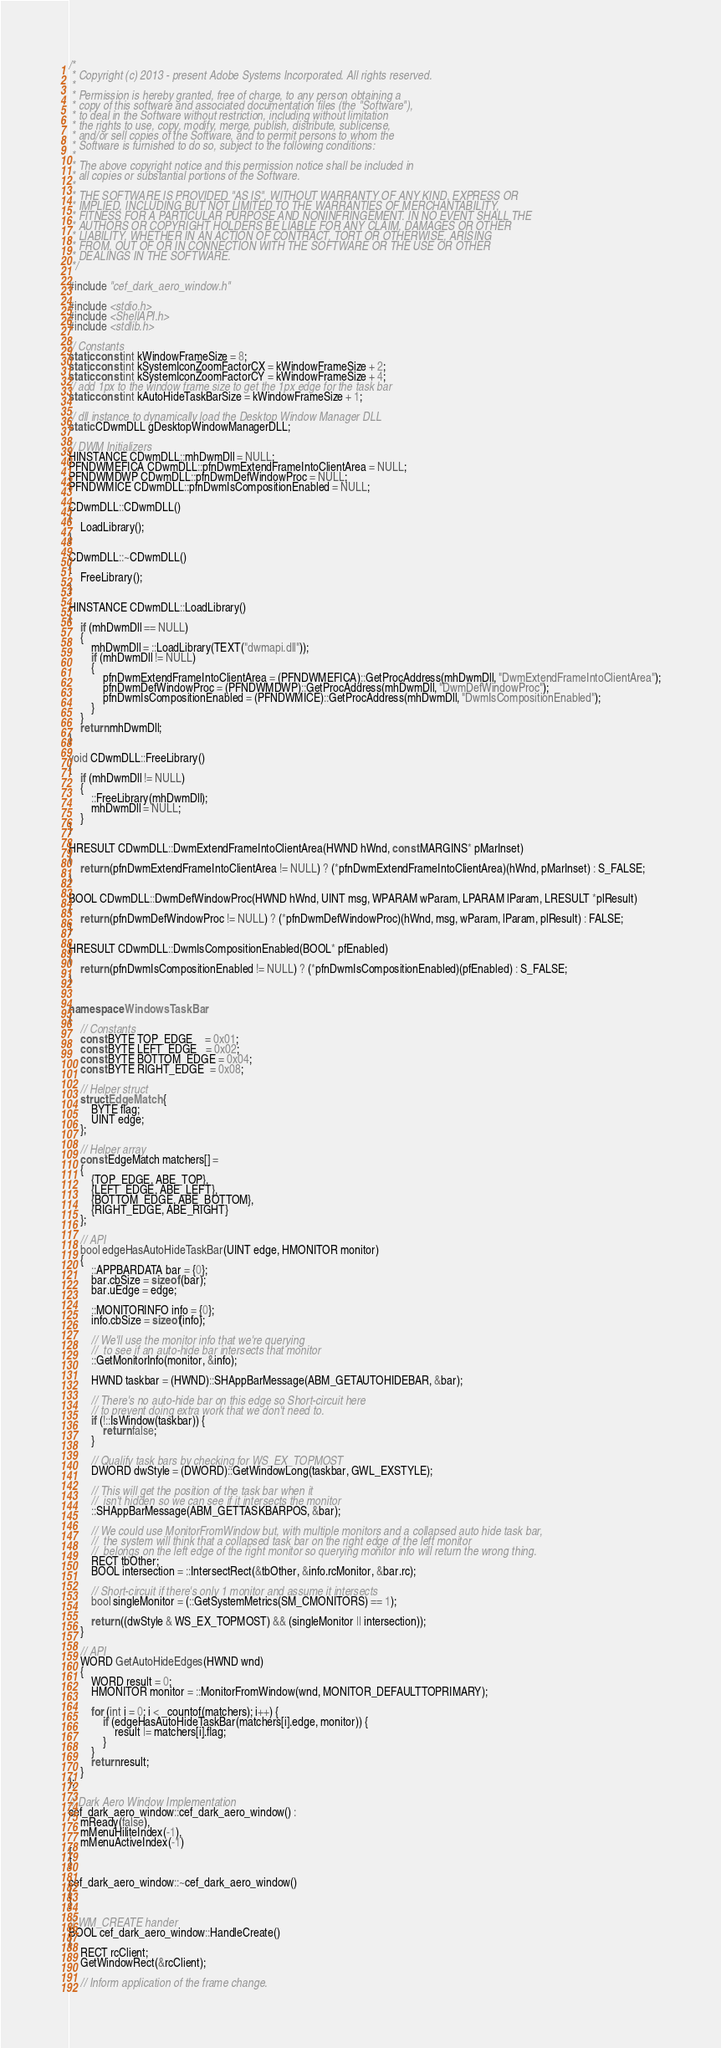Convert code to text. <code><loc_0><loc_0><loc_500><loc_500><_C++_>/*
 * Copyright (c) 2013 - present Adobe Systems Incorporated. All rights reserved.
 *
 * Permission is hereby granted, free of charge, to any person obtaining a
 * copy of this software and associated documentation files (the "Software"),
 * to deal in the Software without restriction, including without limitation
 * the rights to use, copy, modify, merge, publish, distribute, sublicense,
 * and/or sell copies of the Software, and to permit persons to whom the
 * Software is furnished to do so, subject to the following conditions:
 *
 * The above copyright notice and this permission notice shall be included in
 * all copies or substantial portions of the Software.
 *
 * THE SOFTWARE IS PROVIDED "AS IS", WITHOUT WARRANTY OF ANY KIND, EXPRESS OR
 * IMPLIED, INCLUDING BUT NOT LIMITED TO THE WARRANTIES OF MERCHANTABILITY,
 * FITNESS FOR A PARTICULAR PURPOSE AND NONINFRINGEMENT. IN NO EVENT SHALL THE
 * AUTHORS OR COPYRIGHT HOLDERS BE LIABLE FOR ANY CLAIM, DAMAGES OR OTHER
 * LIABILITY, WHETHER IN AN ACTION OF CONTRACT, TORT OR OTHERWISE, ARISING
 * FROM, OUT OF OR IN CONNECTION WITH THE SOFTWARE OR THE USE OR OTHER
 * DEALINGS IN THE SOFTWARE.
 */

#include "cef_dark_aero_window.h"

#include <stdio.h>
#include <ShellAPI.h>
#include <stdlib.h>

// Constants
static const int kWindowFrameSize = 8;
static const int kSystemIconZoomFactorCX = kWindowFrameSize + 2;
static const int kSystemIconZoomFactorCY = kWindowFrameSize + 4;
// add 1px to the window frame size to get the 1px edge for the task bar
static const int kAutoHideTaskBarSize = kWindowFrameSize + 1; 

// dll instance to dynamically load the Desktop Window Manager DLL
static CDwmDLL gDesktopWindowManagerDLL;

// DWM Initializers 
HINSTANCE CDwmDLL::mhDwmDll = NULL;
PFNDWMEFICA CDwmDLL::pfnDwmExtendFrameIntoClientArea = NULL;
PFNDWMDWP CDwmDLL::pfnDwmDefWindowProc = NULL;
PFNDWMICE CDwmDLL::pfnDwmIsCompositionEnabled = NULL;

CDwmDLL::CDwmDLL()
{
    LoadLibrary();
}

CDwmDLL::~CDwmDLL()
{
    FreeLibrary();
}

HINSTANCE CDwmDLL::LoadLibrary()
{
    if (mhDwmDll == NULL)
    {
        mhDwmDll = ::LoadLibrary(TEXT("dwmapi.dll"));
        if (mhDwmDll != NULL)
        {
            pfnDwmExtendFrameIntoClientArea = (PFNDWMEFICA)::GetProcAddress(mhDwmDll, "DwmExtendFrameIntoClientArea");
            pfnDwmDefWindowProc = (PFNDWMDWP)::GetProcAddress(mhDwmDll, "DwmDefWindowProc");
            pfnDwmIsCompositionEnabled = (PFNDWMICE)::GetProcAddress(mhDwmDll, "DwmIsCompositionEnabled");
        }
    }
    return mhDwmDll;
}

void CDwmDLL::FreeLibrary()
{
    if (mhDwmDll != NULL)
    {
        ::FreeLibrary(mhDwmDll);
        mhDwmDll = NULL;
    }
}

HRESULT CDwmDLL::DwmExtendFrameIntoClientArea(HWND hWnd, const MARGINS* pMarInset)
{
    return (pfnDwmExtendFrameIntoClientArea != NULL) ? (*pfnDwmExtendFrameIntoClientArea)(hWnd, pMarInset) : S_FALSE;
}

BOOL CDwmDLL::DwmDefWindowProc(HWND hWnd, UINT msg, WPARAM wParam, LPARAM lParam, LRESULT *plResult)
{
    return (pfnDwmDefWindowProc != NULL) ? (*pfnDwmDefWindowProc)(hWnd, msg, wParam, lParam, plResult) : FALSE;
}

HRESULT CDwmDLL::DwmIsCompositionEnabled(BOOL* pfEnabled)
{
    return (pfnDwmIsCompositionEnabled != NULL) ? (*pfnDwmIsCompositionEnabled)(pfEnabled) : S_FALSE;
}


namespace WindowsTaskBar
{
    // Constants
    const BYTE TOP_EDGE    = 0x01;
    const BYTE LEFT_EDGE   = 0x02;
    const BYTE BOTTOM_EDGE = 0x04;
    const BYTE RIGHT_EDGE  = 0x08;

    // Helper struct
    struct EdgeMatch {
        BYTE flag;
        UINT edge;
    };

    // Helper array
    const EdgeMatch matchers[] = 
    {
        {TOP_EDGE, ABE_TOP},
        {LEFT_EDGE, ABE_LEFT},
        {BOTTOM_EDGE, ABE_BOTTOM},
        {RIGHT_EDGE, ABE_RIGHT}
    };

    // API
    bool edgeHasAutoHideTaskBar(UINT edge, HMONITOR monitor) 
    {
        ::APPBARDATA bar = {0};
        bar.cbSize = sizeof (bar);
        bar.uEdge = edge;

        ::MONITORINFO info = {0};
        info.cbSize = sizeof(info);

        // We'll use the monitor info that we're querying
        //  to see if an auto-hide bar intersects that monitor
        ::GetMonitorInfo(monitor, &info);

        HWND taskbar = (HWND)::SHAppBarMessage(ABM_GETAUTOHIDEBAR, &bar);
    
        // There's no auto-hide bar on this edge so Short-circuit here 
        // to prevent doing extra work that we don't need to. 
        if (!::IsWindow(taskbar)) {
            return false;
        }

        // Qualify task bars by checking for WS_EX_TOPMOST
        DWORD dwStyle = (DWORD)::GetWindowLong(taskbar, GWL_EXSTYLE);

        // This will get the position of the task bar when it
        //  isn't hidden so we can see if it intersects the monitor
        ::SHAppBarMessage(ABM_GETTASKBARPOS, &bar);

        // We could use MonitorFromWindow but, with multiple monitors and a collapsed auto hide task bar,
        //  the system will think that a collapsed task bar on the right edge of the left monitor 
        //  belongs on the left edge of the right monitor so querying monitor info will return the wrong thing.
        RECT tbOther;
        BOOL intersection = ::IntersectRect(&tbOther, &info.rcMonitor, &bar.rc);

        // Short-circuit if there's only 1 monitor and assume it intersects
        bool singleMonitor = (::GetSystemMetrics(SM_CMONITORS) == 1);

        return ((dwStyle & WS_EX_TOPMOST) && (singleMonitor || intersection));
    }

    // API
    WORD GetAutoHideEdges(HWND wnd) 
    {
        WORD result = 0;
        HMONITOR monitor = ::MonitorFromWindow(wnd, MONITOR_DEFAULTTOPRIMARY);
    
        for (int i = 0; i < _countof(matchers); i++) {
            if (edgeHasAutoHideTaskBar(matchers[i].edge, monitor)) {
                result |= matchers[i].flag;
            }
        }
        return result;
    }
};

// Dark Aero Window Implementation
cef_dark_aero_window::cef_dark_aero_window() :
    mReady(false),
    mMenuHiliteIndex(-1),
    mMenuActiveIndex(-1)
{
}

cef_dark_aero_window::~cef_dark_aero_window()
{
}

// WM_CREATE hander
BOOL cef_dark_aero_window::HandleCreate()
{
    RECT rcClient;
    GetWindowRect(&rcClient);

    // Inform application of the frame change.</code> 